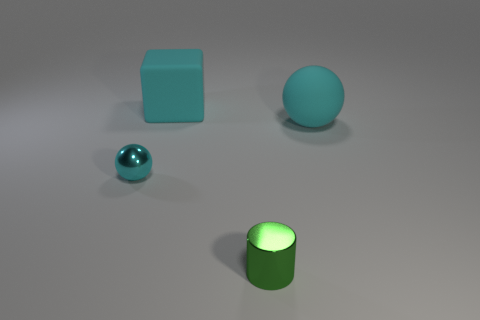How does the lighting in the image affect the appearance of the objects? The lighting creates soft shadows and subtle highlights on the objects, enhancing their three-dimensional form and texture. The direction of the light seems to be coming from the upper right, given the placement of shadows. This lighting setup helps to differentiate the matte and metallic surfaces by how they reflect light, giving a realistic and tangible quality to the scene. Does the lighting suggest any particular time of day or setting? The lighting in the image is neutral and controlled, more akin to a studio lighting setup than natural light. It lacks the color temperature variations typically associated with different times of day, so we can't infer a specific time or natural setting from this alone. It's designed to showcase the objects without any environmental storytelling. 